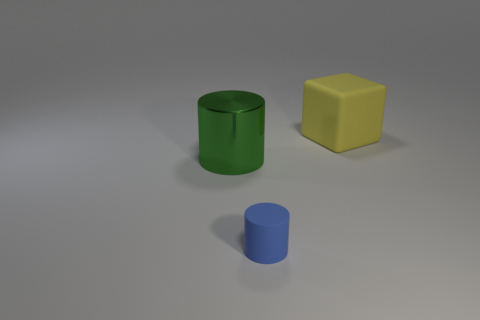Is the number of blue rubber cylinders that are right of the blue rubber cylinder less than the number of things that are in front of the yellow matte block?
Your response must be concise. Yes. Is there anything else that is the same shape as the large rubber object?
Offer a terse response. No. What color is the tiny thing that is the same shape as the big green metallic object?
Your response must be concise. Blue. Do the metallic object and the object that is in front of the big green object have the same shape?
Give a very brief answer. Yes. How many things are large things to the right of the big cylinder or rubber objects that are in front of the large matte block?
Make the answer very short. 2. What is the large cylinder made of?
Keep it short and to the point. Metal. How many other objects are there of the same size as the green metallic object?
Your answer should be compact. 1. How big is the object in front of the metal thing?
Keep it short and to the point. Small. What is the material of the thing that is to the left of the matte thing that is left of the large object that is behind the big green thing?
Offer a very short reply. Metal. Do the metallic thing and the blue thing have the same shape?
Your response must be concise. Yes. 